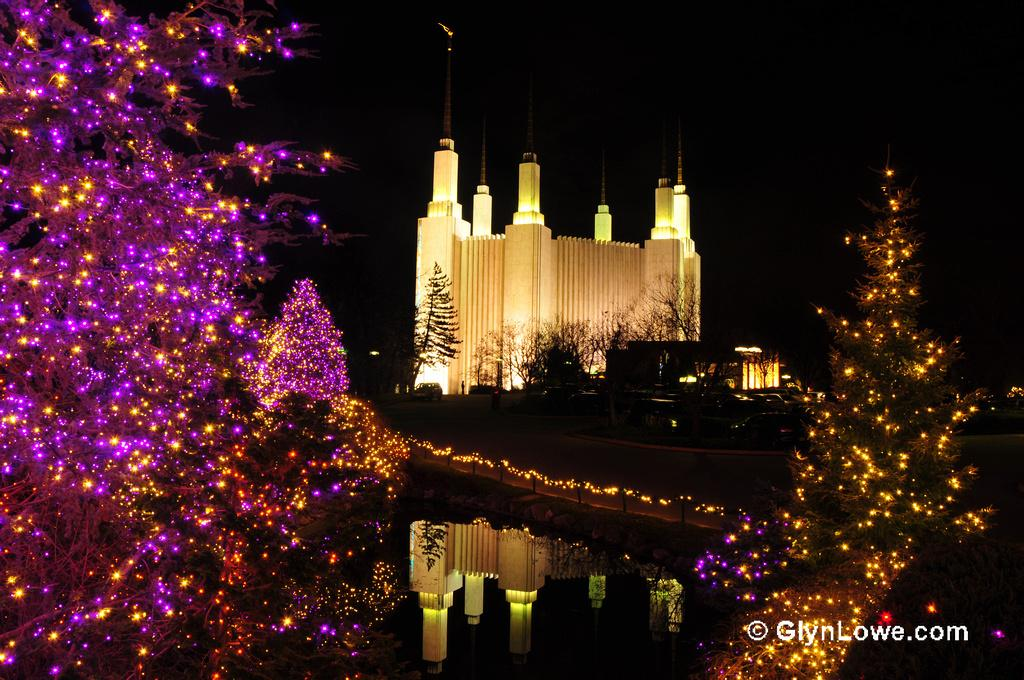What type of structures can be seen in the image? There are buildings in the image. What natural elements are present in the image? There are trees and water visible in the image. What man-made objects can be seen in the image? There are vehicles and decorative lights visible in the image. What is the color of the sky in the image? The sky is dark in the image. Is there any text or logo present in the image? Yes, there is a watermark at the bottom of the image. What type of corn is being used to butter the sleeping person in the image? There is no corn, butter, or sleeping person present in the image. 